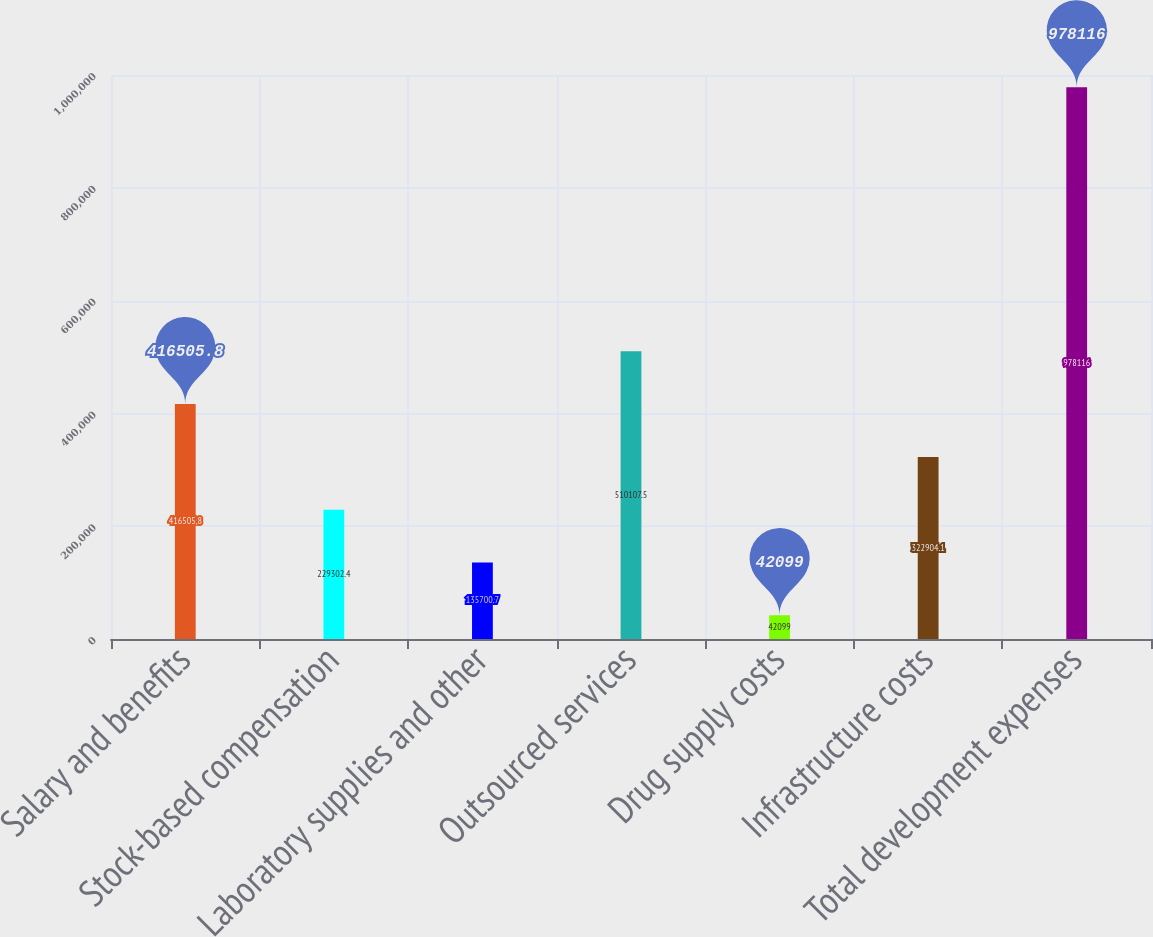<chart> <loc_0><loc_0><loc_500><loc_500><bar_chart><fcel>Salary and benefits<fcel>Stock-based compensation<fcel>Laboratory supplies and other<fcel>Outsourced services<fcel>Drug supply costs<fcel>Infrastructure costs<fcel>Total development expenses<nl><fcel>416506<fcel>229302<fcel>135701<fcel>510108<fcel>42099<fcel>322904<fcel>978116<nl></chart> 